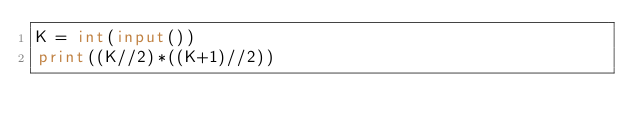Convert code to text. <code><loc_0><loc_0><loc_500><loc_500><_Python_>K = int(input())
print((K//2)*((K+1)//2))
</code> 